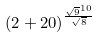Convert formula to latex. <formula><loc_0><loc_0><loc_500><loc_500>( 2 + 2 0 ) ^ { \frac { \sqrt { 9 } ^ { 1 0 } } { \sqrt { 8 } } }</formula> 